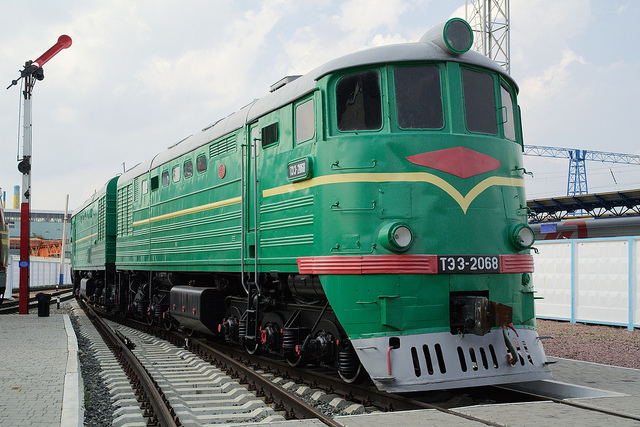Please transcribe the text information in this image. T33-2068 